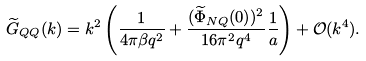Convert formula to latex. <formula><loc_0><loc_0><loc_500><loc_500>\widetilde { G } _ { Q Q } ( k ) = k ^ { 2 } \left ( \frac { 1 } { 4 \pi \beta q ^ { 2 } } + \frac { ( \widetilde { \Phi } _ { N Q } ( 0 ) ) ^ { 2 } } { 1 6 \pi ^ { 2 } q ^ { 4 } } \frac { 1 } { a } \right ) + \mathcal { O } ( k ^ { 4 } ) .</formula> 